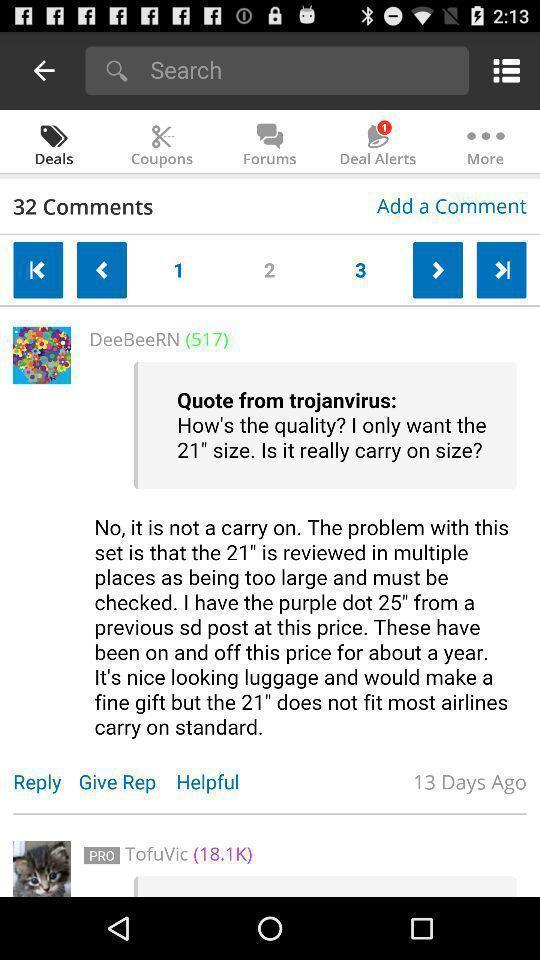Tell me what you see in this picture. Search page with options in the business app. 